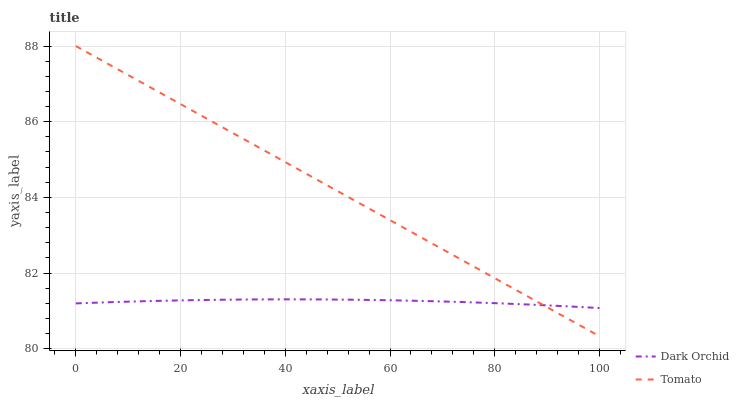Does Dark Orchid have the minimum area under the curve?
Answer yes or no. Yes. Does Tomato have the maximum area under the curve?
Answer yes or no. Yes. Does Dark Orchid have the maximum area under the curve?
Answer yes or no. No. Is Tomato the smoothest?
Answer yes or no. Yes. Is Dark Orchid the roughest?
Answer yes or no. Yes. Is Dark Orchid the smoothest?
Answer yes or no. No. Does Dark Orchid have the lowest value?
Answer yes or no. No. Does Dark Orchid have the highest value?
Answer yes or no. No. 